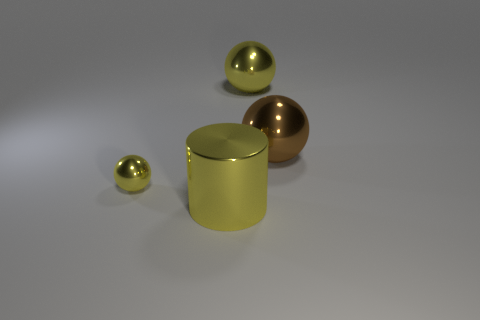Add 3 yellow metallic cylinders. How many objects exist? 7 Subtract all cylinders. How many objects are left? 3 Subtract 0 red balls. How many objects are left? 4 Subtract all brown spheres. Subtract all metal spheres. How many objects are left? 0 Add 3 brown shiny spheres. How many brown shiny spheres are left? 4 Add 3 big yellow shiny cylinders. How many big yellow shiny cylinders exist? 4 